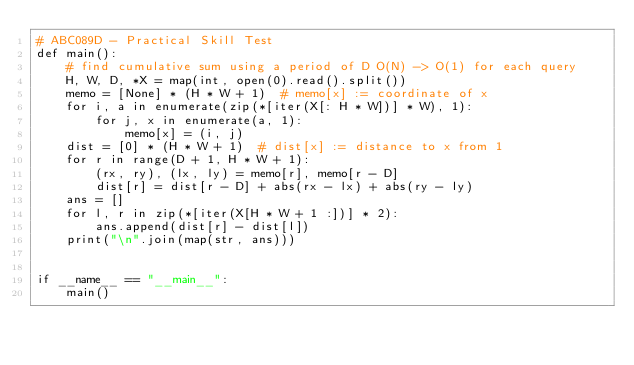<code> <loc_0><loc_0><loc_500><loc_500><_Python_># ABC089D - Practical Skill Test
def main():
    # find cumulative sum using a period of D O(N) -> O(1) for each query
    H, W, D, *X = map(int, open(0).read().split())
    memo = [None] * (H * W + 1)  # memo[x] := coordinate of x
    for i, a in enumerate(zip(*[iter(X[: H * W])] * W), 1):
        for j, x in enumerate(a, 1):
            memo[x] = (i, j)
    dist = [0] * (H * W + 1)  # dist[x] := distance to x from 1
    for r in range(D + 1, H * W + 1):
        (rx, ry), (lx, ly) = memo[r], memo[r - D]
        dist[r] = dist[r - D] + abs(rx - lx) + abs(ry - ly)
    ans = []
    for l, r in zip(*[iter(X[H * W + 1 :])] * 2):
        ans.append(dist[r] - dist[l])
    print("\n".join(map(str, ans)))


if __name__ == "__main__":
    main()</code> 